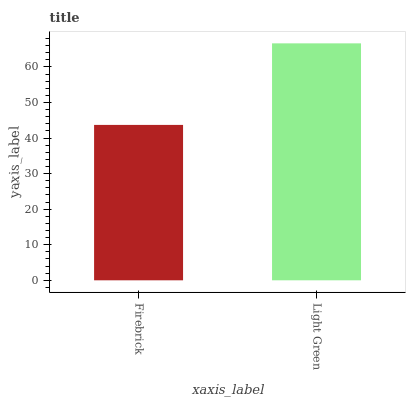Is Firebrick the minimum?
Answer yes or no. Yes. Is Light Green the maximum?
Answer yes or no. Yes. Is Light Green the minimum?
Answer yes or no. No. Is Light Green greater than Firebrick?
Answer yes or no. Yes. Is Firebrick less than Light Green?
Answer yes or no. Yes. Is Firebrick greater than Light Green?
Answer yes or no. No. Is Light Green less than Firebrick?
Answer yes or no. No. Is Light Green the high median?
Answer yes or no. Yes. Is Firebrick the low median?
Answer yes or no. Yes. Is Firebrick the high median?
Answer yes or no. No. Is Light Green the low median?
Answer yes or no. No. 